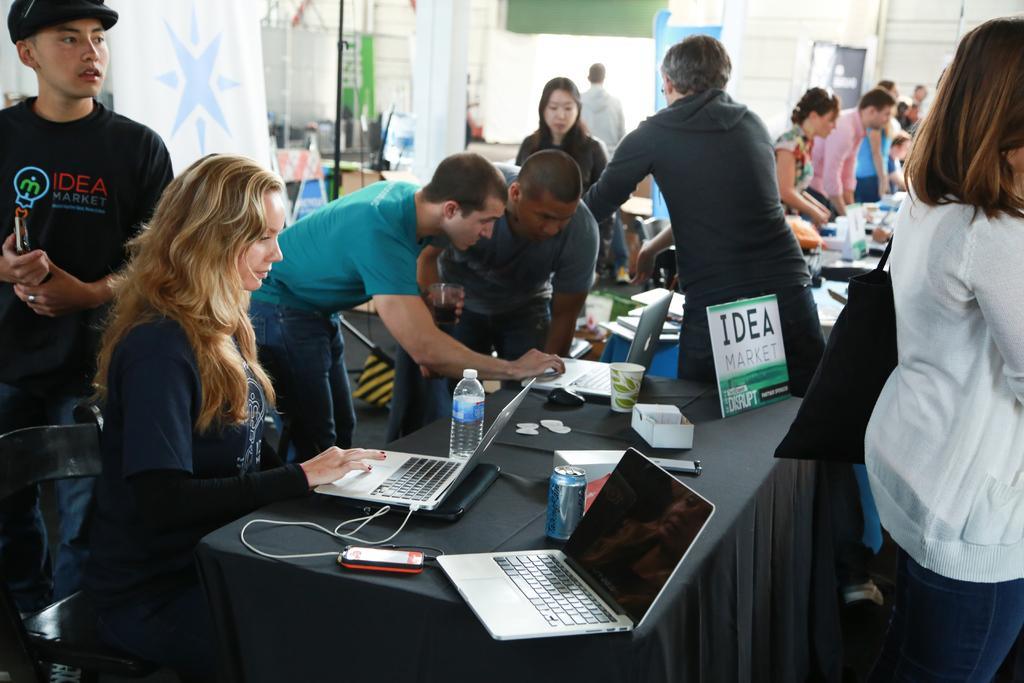How would you summarize this image in a sentence or two? In this image I can see few people are standing and few people are working on the laptops which are placed on the table. This table is covered with a black color cloth. On this I can see laptops, boxes, glasses, bottle, mobile, wires and some more objects. In the background there is a wall and pillar. 